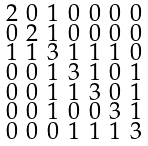<formula> <loc_0><loc_0><loc_500><loc_500>\begin{smallmatrix} 2 & 0 & 1 & 0 & 0 & 0 & 0 \\ 0 & 2 & 1 & 0 & 0 & 0 & 0 \\ 1 & 1 & 3 & 1 & 1 & 1 & 0 \\ 0 & 0 & 1 & 3 & 1 & 0 & 1 \\ 0 & 0 & 1 & 1 & 3 & 0 & 1 \\ 0 & 0 & 1 & 0 & 0 & 3 & 1 \\ 0 & 0 & 0 & 1 & 1 & 1 & 3 \end{smallmatrix}</formula> 